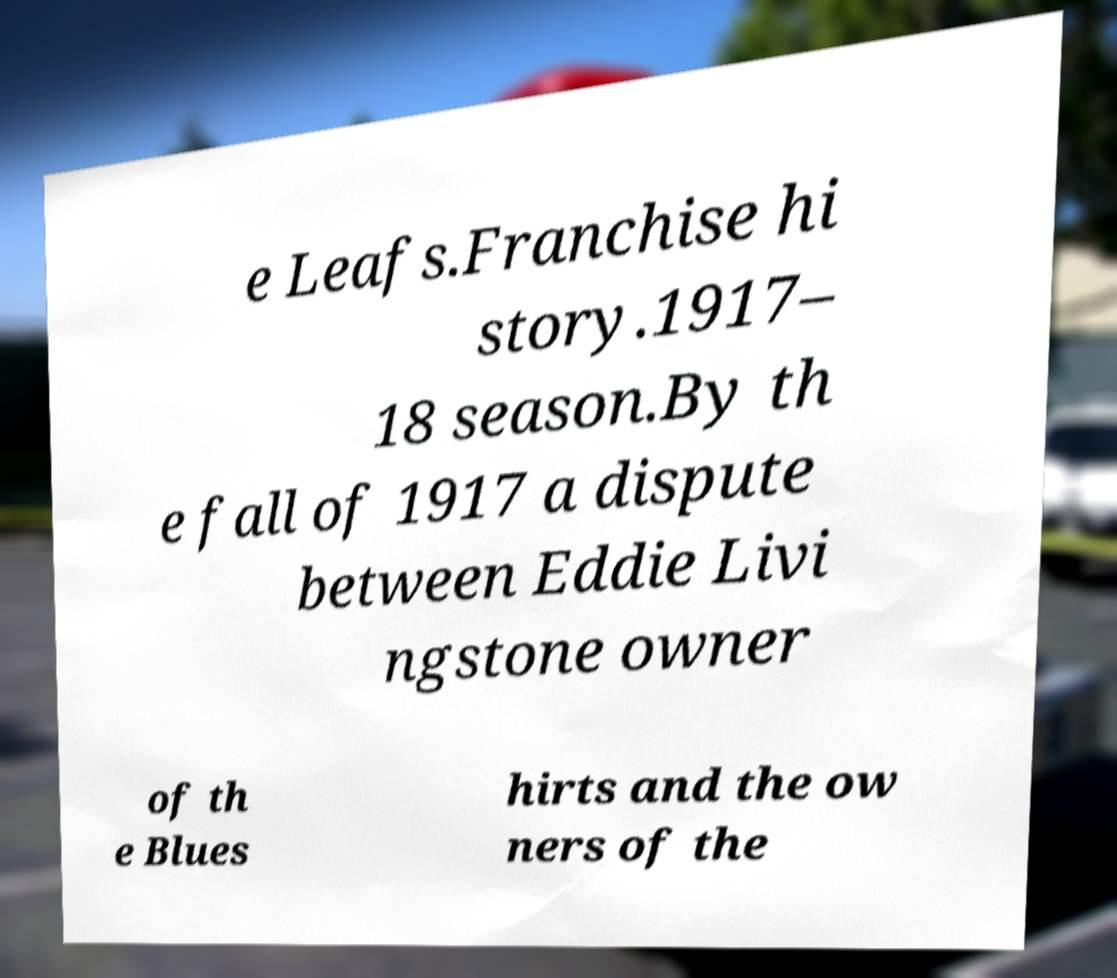What messages or text are displayed in this image? I need them in a readable, typed format. e Leafs.Franchise hi story.1917– 18 season.By th e fall of 1917 a dispute between Eddie Livi ngstone owner of th e Blues hirts and the ow ners of the 